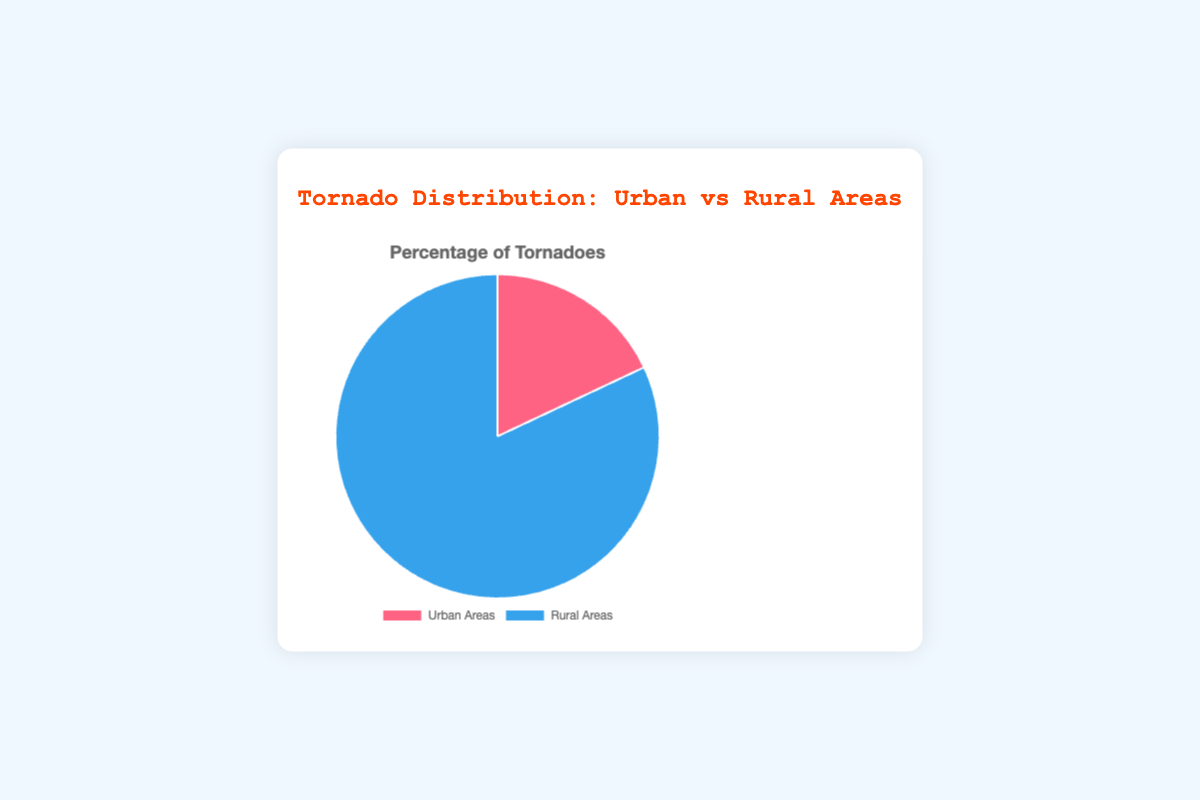What percentage of tornadoes occur in urban areas? From the pie chart, the label "Urban Areas" shows a percentage of 18%. Thus, we can directly read the percentage of tornadoes occurring in urban areas.
Answer: 18% How many times more common are tornadoes in rural areas compared to urban areas? To determine this, divide the percentage of tornadoes in rural areas (82%) by the percentage in urban areas (18%). This calculation yields approximately 4.56 times.
Answer: 4.56 times Which area type has a greater percentage of tornadoes? By comparing the percentages, rural areas have 82% while urban areas have 18%. 82% is greater than 18%.
Answer: Rural Areas What fraction of tornadoes occurs in rural areas? To convert the percentage in rural areas (82%) to a fraction, divide by 100. 82% becomes 82/100, which simplifies to 41/50.
Answer: 41/50 Do urban areas experience less than one-quarter of the total tornadoes? One-quarter (1/4) of 100% is 25%. Since 18% is less than 25%, urban areas experience less than one-quarter of tornadoes.
Answer: Yes What is the difference in tornado occurrence between rural and urban areas? Subtract the percentage in urban areas from the percentage in rural areas: 82% - 18% = 64%.
Answer: 64% If we were to look at 1,000 tornado incidents, how many would occur in urban areas? Multiply the percentage of tornadoes in urban areas (18%) by 1,000: 1000 * 0.18 = 180.
Answer: 180 What is the combined percentage of tornadoes in both urban and rural areas? Adding the percentages for urban (18%) and rural (82%) areas gives 18% + 82% = 100%.
Answer: 100% What color represents tornadoes in rural areas on the pie chart? The pie chart uses blue to represent rural areas, as indicated by the background color for "Rural Areas."
Answer: Blue If the total number of tornadoes was 500, how many would occur in rural areas? Multiply the percentage of tornadoes in rural areas (82%) by 500: 500 * 0.82 = 410.
Answer: 410 